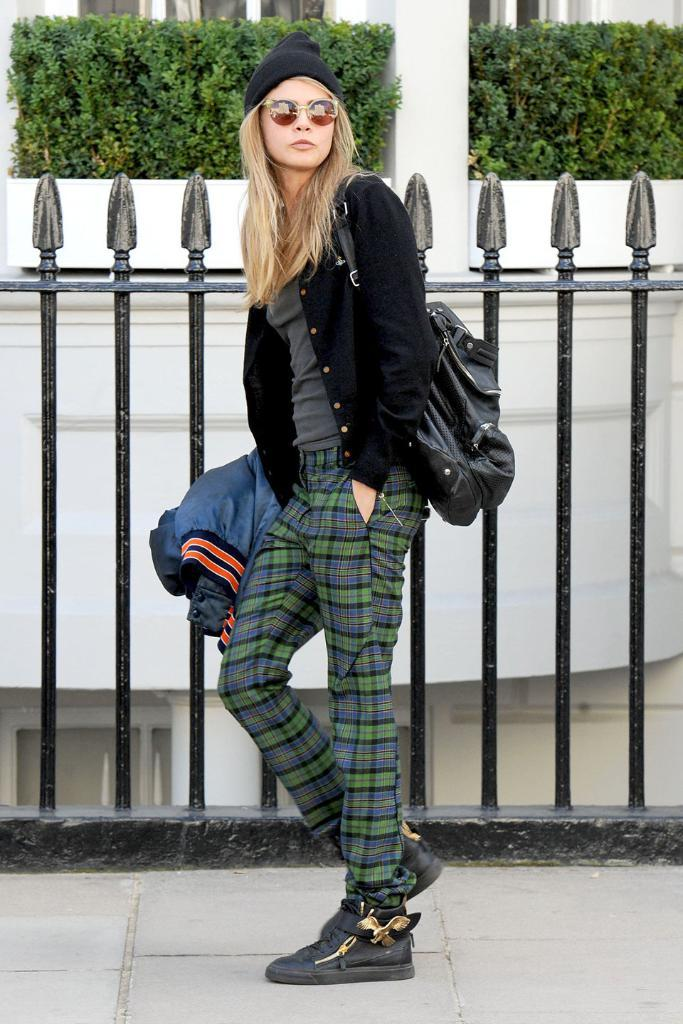What is the woman doing in the image? The woman is standing beside the fence in the image. What can be seen in the background of the image? There is a building with windows in the background. Can you describe the building in the image? The building has pillars. Are there any plants visible in the image? Yes, there are plants visible in the image. How many tigers are visible in the image? There are no tigers present in the image. What type of flower is growing near the fence in the image? There is no flower visible in the image. 